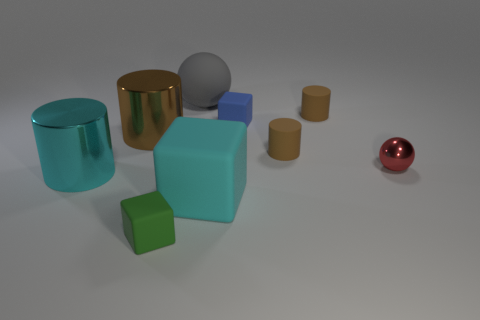Add 1 small green blocks. How many objects exist? 10 Subtract all cyan metal cylinders. How many cylinders are left? 3 Subtract all red cubes. How many brown cylinders are left? 3 Subtract 2 blocks. How many blocks are left? 1 Subtract all cyan cylinders. How many cylinders are left? 3 Subtract all balls. How many objects are left? 7 Subtract 0 purple balls. How many objects are left? 9 Subtract all blue blocks. Subtract all blue balls. How many blocks are left? 2 Subtract all tiny brown things. Subtract all cyan matte things. How many objects are left? 6 Add 3 big cubes. How many big cubes are left? 4 